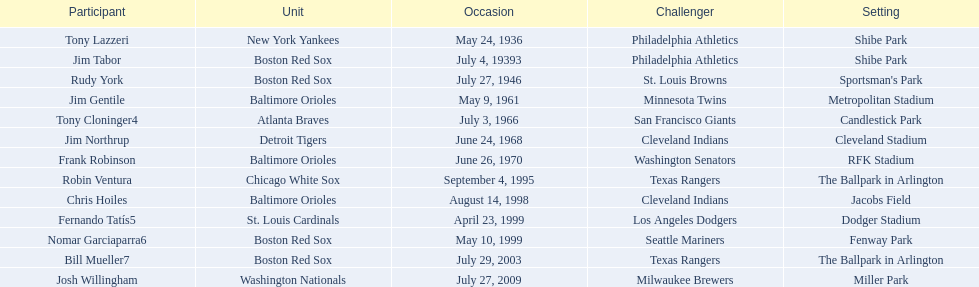Who are all the opponents? Philadelphia Athletics, Philadelphia Athletics, St. Louis Browns, Minnesota Twins, San Francisco Giants, Cleveland Indians, Washington Senators, Texas Rangers, Cleveland Indians, Los Angeles Dodgers, Seattle Mariners, Texas Rangers, Milwaukee Brewers. What teams played on july 27, 1946? Boston Red Sox, July 27, 1946, St. Louis Browns. Who was the opponent in this game? St. Louis Browns. 